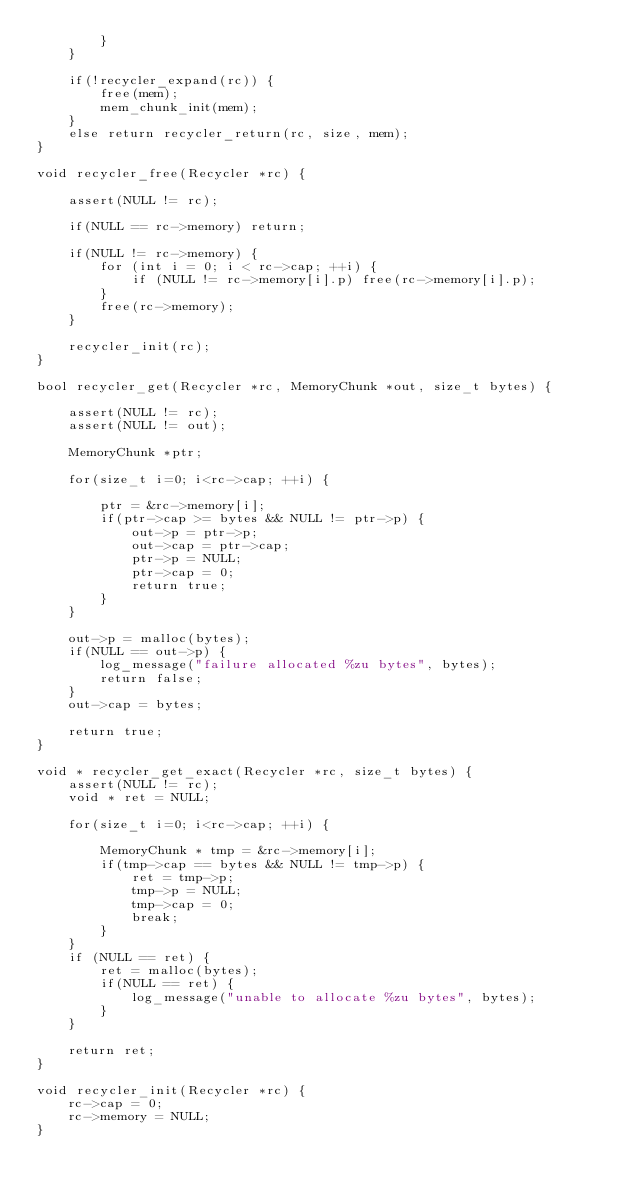<code> <loc_0><loc_0><loc_500><loc_500><_C_>        }
    }

    if(!recycler_expand(rc)) {
        free(mem);
        mem_chunk_init(mem);
    }
    else return recycler_return(rc, size, mem);
}

void recycler_free(Recycler *rc) {

    assert(NULL != rc);

    if(NULL == rc->memory) return;

    if(NULL != rc->memory) {
        for (int i = 0; i < rc->cap; ++i) {
            if (NULL != rc->memory[i].p) free(rc->memory[i].p);
        }
        free(rc->memory);
    }

    recycler_init(rc);
}

bool recycler_get(Recycler *rc, MemoryChunk *out, size_t bytes) {

    assert(NULL != rc);
    assert(NULL != out);

    MemoryChunk *ptr;

    for(size_t i=0; i<rc->cap; ++i) {

        ptr = &rc->memory[i];
        if(ptr->cap >= bytes && NULL != ptr->p) {
            out->p = ptr->p;
            out->cap = ptr->cap;
            ptr->p = NULL;
            ptr->cap = 0;
            return true;
        }
    }

    out->p = malloc(bytes);
    if(NULL == out->p) {
        log_message("failure allocated %zu bytes", bytes);
        return false;
    }
    out->cap = bytes;

    return true;
}

void * recycler_get_exact(Recycler *rc, size_t bytes) {
    assert(NULL != rc);
    void * ret = NULL;

    for(size_t i=0; i<rc->cap; ++i) {

        MemoryChunk * tmp = &rc->memory[i];
        if(tmp->cap == bytes && NULL != tmp->p) {
            ret = tmp->p;
            tmp->p = NULL;
            tmp->cap = 0;
            break;
        }
    }
    if (NULL == ret) {
        ret = malloc(bytes);
        if(NULL == ret) {
            log_message("unable to allocate %zu bytes", bytes);
        }
    }

    return ret;
}

void recycler_init(Recycler *rc) {
    rc->cap = 0;
    rc->memory = NULL;
}</code> 